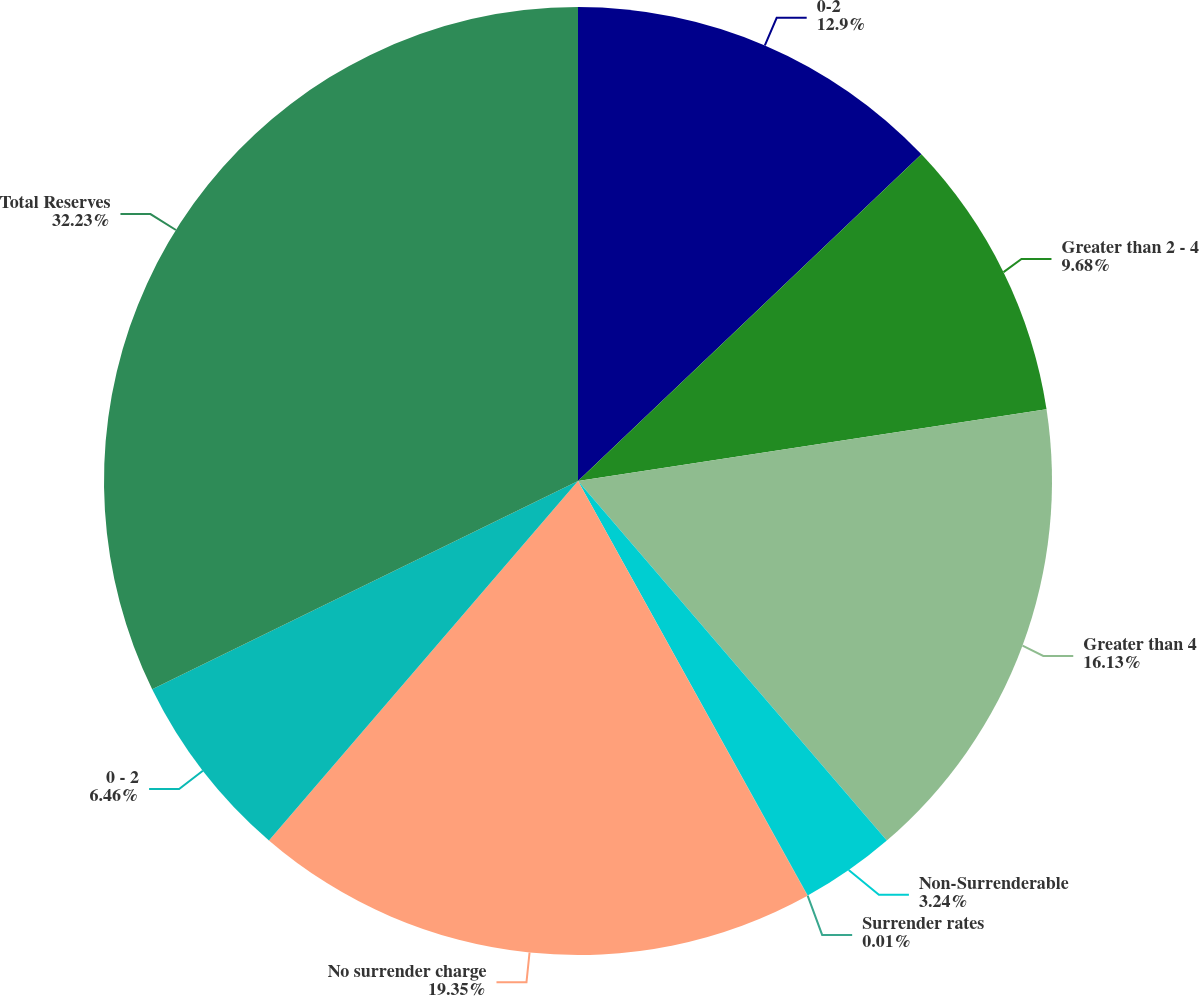Convert chart. <chart><loc_0><loc_0><loc_500><loc_500><pie_chart><fcel>0-2<fcel>Greater than 2 - 4<fcel>Greater than 4<fcel>Non-Surrenderable<fcel>Surrender rates<fcel>No surrender charge<fcel>0 - 2<fcel>Total Reserves<nl><fcel>12.9%<fcel>9.68%<fcel>16.13%<fcel>3.24%<fcel>0.01%<fcel>19.35%<fcel>6.46%<fcel>32.24%<nl></chart> 